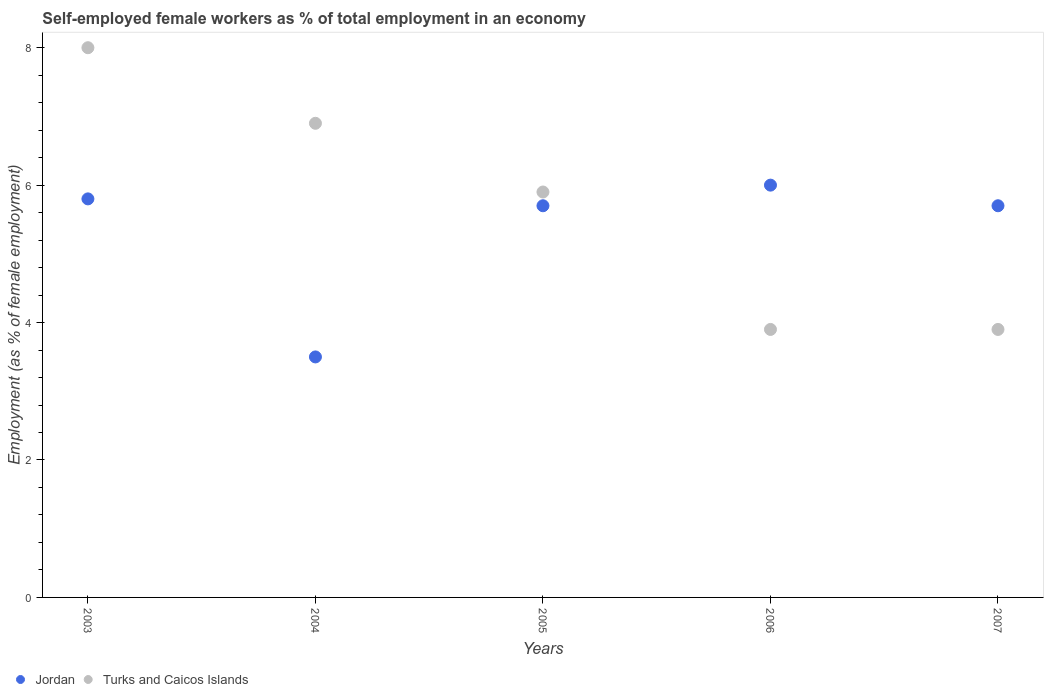How many different coloured dotlines are there?
Offer a terse response. 2. Is the number of dotlines equal to the number of legend labels?
Offer a terse response. Yes. What is the percentage of self-employed female workers in Turks and Caicos Islands in 2007?
Ensure brevity in your answer.  3.9. Across all years, what is the minimum percentage of self-employed female workers in Turks and Caicos Islands?
Give a very brief answer. 3.9. In which year was the percentage of self-employed female workers in Turks and Caicos Islands maximum?
Provide a succinct answer. 2003. In which year was the percentage of self-employed female workers in Jordan minimum?
Give a very brief answer. 2004. What is the total percentage of self-employed female workers in Jordan in the graph?
Make the answer very short. 26.7. What is the difference between the percentage of self-employed female workers in Jordan in 2004 and that in 2005?
Offer a very short reply. -2.2. What is the difference between the percentage of self-employed female workers in Jordan in 2005 and the percentage of self-employed female workers in Turks and Caicos Islands in 2007?
Offer a terse response. 1.8. What is the average percentage of self-employed female workers in Jordan per year?
Provide a succinct answer. 5.34. In the year 2006, what is the difference between the percentage of self-employed female workers in Jordan and percentage of self-employed female workers in Turks and Caicos Islands?
Offer a very short reply. 2.1. What is the ratio of the percentage of self-employed female workers in Jordan in 2004 to that in 2007?
Your answer should be compact. 0.61. Is the difference between the percentage of self-employed female workers in Jordan in 2004 and 2007 greater than the difference between the percentage of self-employed female workers in Turks and Caicos Islands in 2004 and 2007?
Your answer should be very brief. No. What is the difference between the highest and the second highest percentage of self-employed female workers in Jordan?
Offer a terse response. 0.2. What is the difference between the highest and the lowest percentage of self-employed female workers in Turks and Caicos Islands?
Your answer should be very brief. 4.1. Is the sum of the percentage of self-employed female workers in Turks and Caicos Islands in 2005 and 2007 greater than the maximum percentage of self-employed female workers in Jordan across all years?
Provide a short and direct response. Yes. Does the percentage of self-employed female workers in Turks and Caicos Islands monotonically increase over the years?
Your answer should be compact. No. Is the percentage of self-employed female workers in Jordan strictly greater than the percentage of self-employed female workers in Turks and Caicos Islands over the years?
Ensure brevity in your answer.  No. What is the difference between two consecutive major ticks on the Y-axis?
Provide a short and direct response. 2. Are the values on the major ticks of Y-axis written in scientific E-notation?
Make the answer very short. No. Does the graph contain grids?
Provide a short and direct response. No. How many legend labels are there?
Provide a succinct answer. 2. How are the legend labels stacked?
Offer a terse response. Horizontal. What is the title of the graph?
Provide a succinct answer. Self-employed female workers as % of total employment in an economy. What is the label or title of the X-axis?
Provide a succinct answer. Years. What is the label or title of the Y-axis?
Provide a succinct answer. Employment (as % of female employment). What is the Employment (as % of female employment) of Jordan in 2003?
Your response must be concise. 5.8. What is the Employment (as % of female employment) in Turks and Caicos Islands in 2003?
Your answer should be very brief. 8. What is the Employment (as % of female employment) in Jordan in 2004?
Your answer should be very brief. 3.5. What is the Employment (as % of female employment) in Turks and Caicos Islands in 2004?
Ensure brevity in your answer.  6.9. What is the Employment (as % of female employment) of Jordan in 2005?
Your answer should be compact. 5.7. What is the Employment (as % of female employment) of Turks and Caicos Islands in 2005?
Your answer should be compact. 5.9. What is the Employment (as % of female employment) in Turks and Caicos Islands in 2006?
Your response must be concise. 3.9. What is the Employment (as % of female employment) in Jordan in 2007?
Your response must be concise. 5.7. What is the Employment (as % of female employment) in Turks and Caicos Islands in 2007?
Your answer should be compact. 3.9. Across all years, what is the minimum Employment (as % of female employment) in Turks and Caicos Islands?
Provide a succinct answer. 3.9. What is the total Employment (as % of female employment) in Jordan in the graph?
Keep it short and to the point. 26.7. What is the total Employment (as % of female employment) of Turks and Caicos Islands in the graph?
Your answer should be very brief. 28.6. What is the difference between the Employment (as % of female employment) in Jordan in 2003 and that in 2006?
Provide a succinct answer. -0.2. What is the difference between the Employment (as % of female employment) of Jordan in 2003 and that in 2007?
Keep it short and to the point. 0.1. What is the difference between the Employment (as % of female employment) in Turks and Caicos Islands in 2004 and that in 2005?
Your answer should be very brief. 1. What is the difference between the Employment (as % of female employment) of Jordan in 2004 and that in 2006?
Offer a terse response. -2.5. What is the difference between the Employment (as % of female employment) of Turks and Caicos Islands in 2004 and that in 2007?
Offer a terse response. 3. What is the difference between the Employment (as % of female employment) of Jordan in 2005 and that in 2007?
Keep it short and to the point. 0. What is the difference between the Employment (as % of female employment) of Jordan in 2006 and that in 2007?
Keep it short and to the point. 0.3. What is the difference between the Employment (as % of female employment) of Jordan in 2003 and the Employment (as % of female employment) of Turks and Caicos Islands in 2004?
Keep it short and to the point. -1.1. What is the difference between the Employment (as % of female employment) of Jordan in 2003 and the Employment (as % of female employment) of Turks and Caicos Islands in 2005?
Keep it short and to the point. -0.1. What is the difference between the Employment (as % of female employment) of Jordan in 2004 and the Employment (as % of female employment) of Turks and Caicos Islands in 2005?
Your response must be concise. -2.4. What is the difference between the Employment (as % of female employment) in Jordan in 2004 and the Employment (as % of female employment) in Turks and Caicos Islands in 2006?
Provide a short and direct response. -0.4. What is the difference between the Employment (as % of female employment) of Jordan in 2004 and the Employment (as % of female employment) of Turks and Caicos Islands in 2007?
Ensure brevity in your answer.  -0.4. What is the difference between the Employment (as % of female employment) of Jordan in 2005 and the Employment (as % of female employment) of Turks and Caicos Islands in 2006?
Ensure brevity in your answer.  1.8. What is the average Employment (as % of female employment) in Jordan per year?
Offer a terse response. 5.34. What is the average Employment (as % of female employment) of Turks and Caicos Islands per year?
Your answer should be compact. 5.72. In the year 2003, what is the difference between the Employment (as % of female employment) in Jordan and Employment (as % of female employment) in Turks and Caicos Islands?
Make the answer very short. -2.2. What is the ratio of the Employment (as % of female employment) in Jordan in 2003 to that in 2004?
Keep it short and to the point. 1.66. What is the ratio of the Employment (as % of female employment) in Turks and Caicos Islands in 2003 to that in 2004?
Ensure brevity in your answer.  1.16. What is the ratio of the Employment (as % of female employment) of Jordan in 2003 to that in 2005?
Give a very brief answer. 1.02. What is the ratio of the Employment (as % of female employment) in Turks and Caicos Islands in 2003 to that in 2005?
Your answer should be compact. 1.36. What is the ratio of the Employment (as % of female employment) in Jordan in 2003 to that in 2006?
Your answer should be compact. 0.97. What is the ratio of the Employment (as % of female employment) of Turks and Caicos Islands in 2003 to that in 2006?
Your answer should be very brief. 2.05. What is the ratio of the Employment (as % of female employment) in Jordan in 2003 to that in 2007?
Your response must be concise. 1.02. What is the ratio of the Employment (as % of female employment) of Turks and Caicos Islands in 2003 to that in 2007?
Provide a short and direct response. 2.05. What is the ratio of the Employment (as % of female employment) in Jordan in 2004 to that in 2005?
Provide a succinct answer. 0.61. What is the ratio of the Employment (as % of female employment) in Turks and Caicos Islands in 2004 to that in 2005?
Provide a succinct answer. 1.17. What is the ratio of the Employment (as % of female employment) in Jordan in 2004 to that in 2006?
Your answer should be compact. 0.58. What is the ratio of the Employment (as % of female employment) of Turks and Caicos Islands in 2004 to that in 2006?
Give a very brief answer. 1.77. What is the ratio of the Employment (as % of female employment) of Jordan in 2004 to that in 2007?
Your answer should be compact. 0.61. What is the ratio of the Employment (as % of female employment) in Turks and Caicos Islands in 2004 to that in 2007?
Make the answer very short. 1.77. What is the ratio of the Employment (as % of female employment) of Turks and Caicos Islands in 2005 to that in 2006?
Keep it short and to the point. 1.51. What is the ratio of the Employment (as % of female employment) in Turks and Caicos Islands in 2005 to that in 2007?
Provide a succinct answer. 1.51. What is the ratio of the Employment (as % of female employment) of Jordan in 2006 to that in 2007?
Make the answer very short. 1.05. What is the difference between the highest and the second highest Employment (as % of female employment) in Jordan?
Make the answer very short. 0.2. What is the difference between the highest and the lowest Employment (as % of female employment) of Jordan?
Make the answer very short. 2.5. 